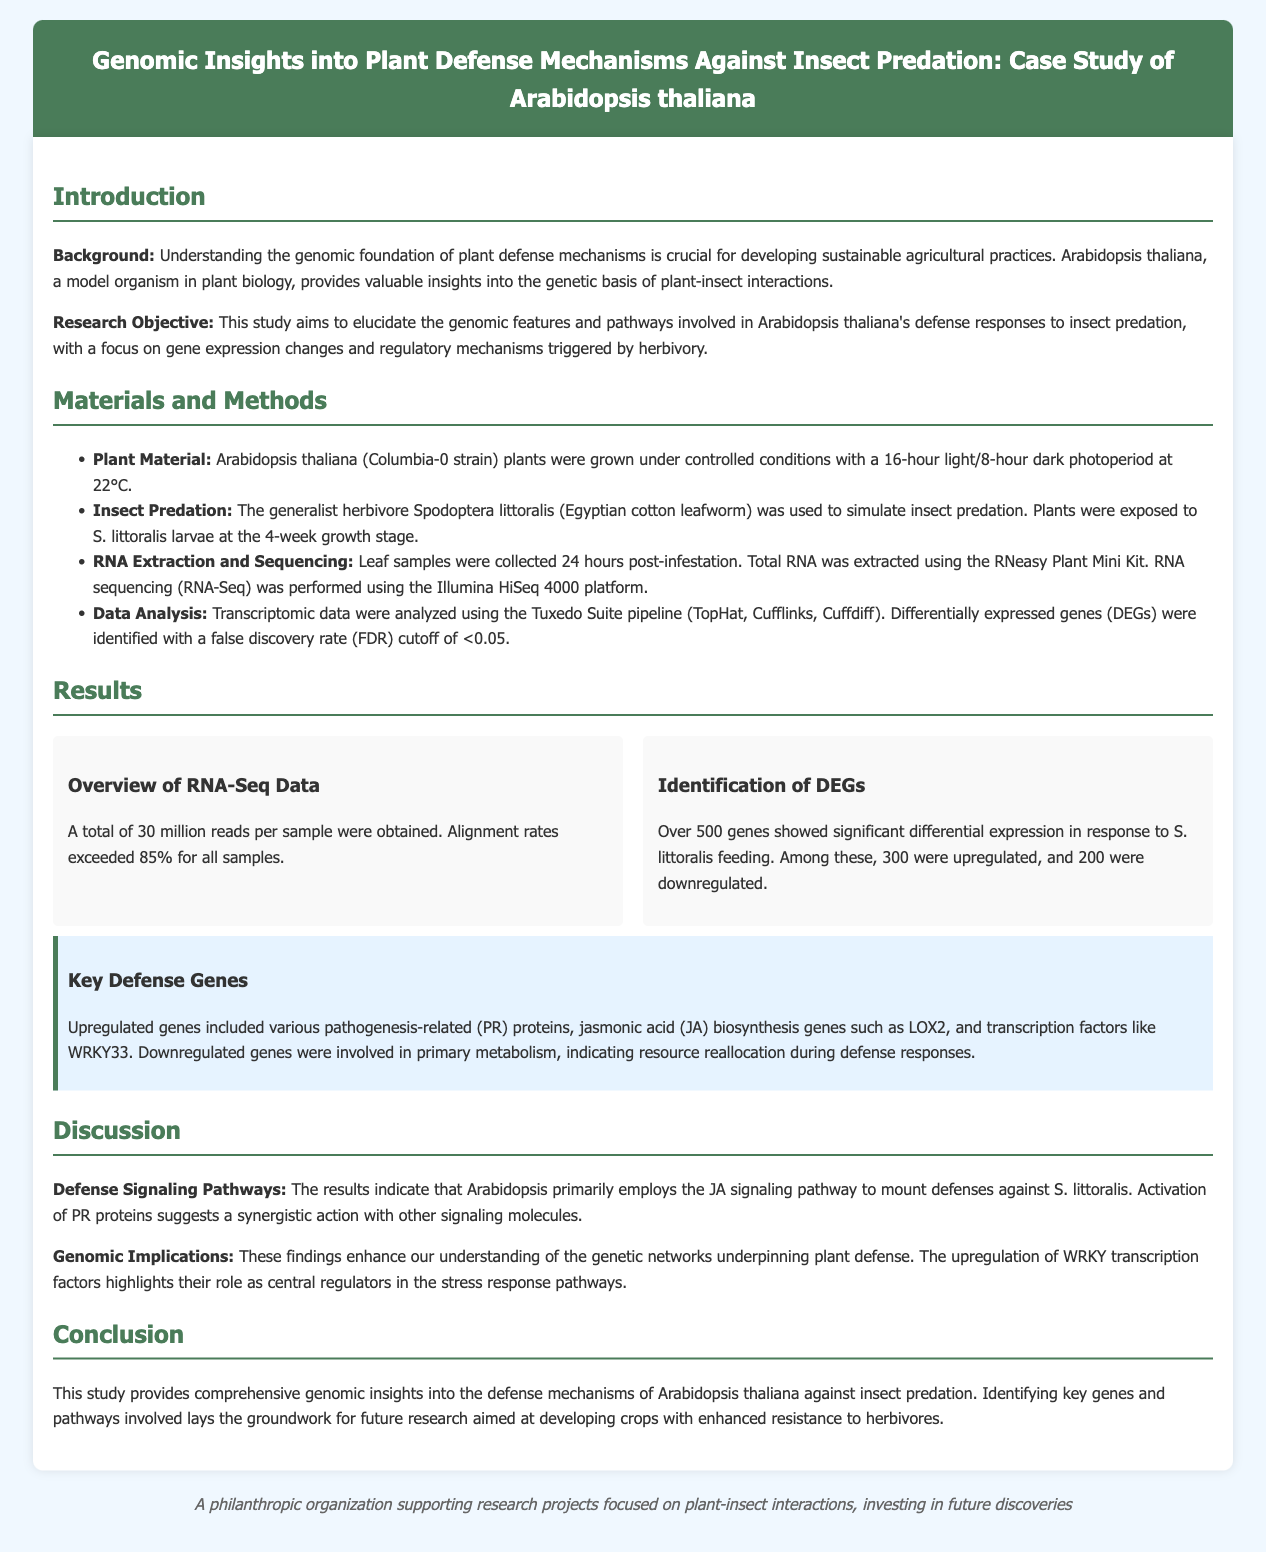what is the title of the study? The title is prominently displayed at the beginning of the document, summarizing the focus of the research on plant defense mechanisms.
Answer: Genomic Insights into Plant Defense Mechanisms Against Insect Predation: Case Study of Arabidopsis thaliana which herbivore was used in the study? The document specifies the particular insect chosen for simulating predation on the Arabidopsis plants within the methods section.
Answer: Spodoptera littoralis how many reads per sample were obtained? The Results section mentions the total number of reads, providing a quantitative measure of the sequencing output.
Answer: 30 million how many differentially expressed genes were identified? In the Results section, the number of genes showing significant expression changes in response to herbivory is clearly stated.
Answer: Over 500 which gene was upregulated that is involved in jasmonic acid biosynthesis? The highlight section outlines key genes that were upregulated, indicating their specific roles in the plant's defense mechanism.
Answer: LOX2 what plant species was used as a model in this study? The Introduction outlines the specific model organism that serves as the basis for the research, highlighting its importance in plant biology.
Answer: Arabidopsis thaliana what was the discovery regarding WRKY transcription factors? The Discussion section addresses the implications of the findings, particularly highlighting the role of a specific family of transcription factors.
Answer: Central regulators what consequence occurred regarding primary metabolism during defense responses? The document points out the implications of gene regulation in terms of resource allocation during plant defense, discussed within the Results section.
Answer: Resource reallocation 